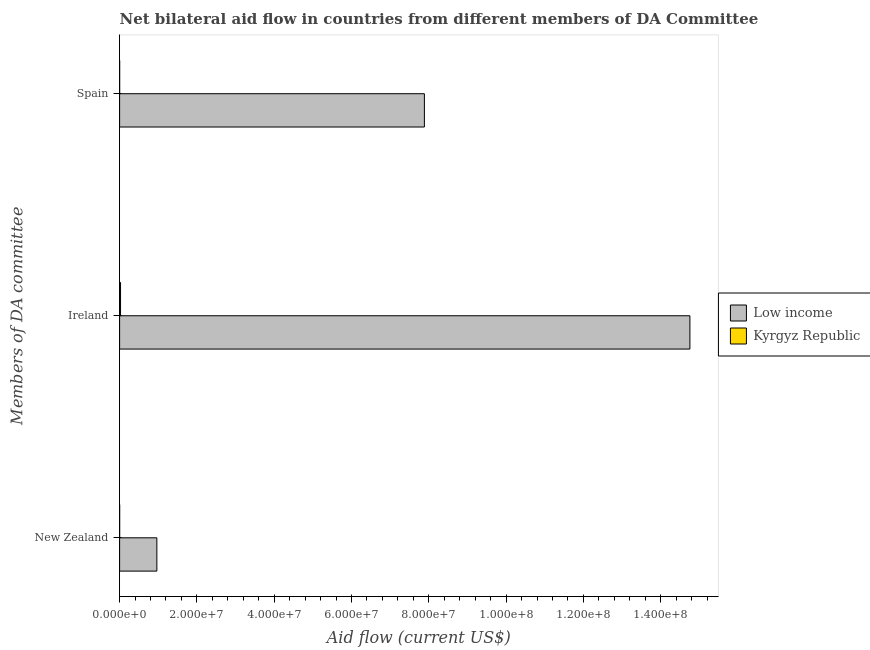How many groups of bars are there?
Ensure brevity in your answer.  3. Are the number of bars per tick equal to the number of legend labels?
Your answer should be compact. Yes. Are the number of bars on each tick of the Y-axis equal?
Keep it short and to the point. Yes. How many bars are there on the 1st tick from the top?
Provide a short and direct response. 2. How many bars are there on the 2nd tick from the bottom?
Ensure brevity in your answer.  2. What is the label of the 3rd group of bars from the top?
Offer a terse response. New Zealand. What is the amount of aid provided by spain in Low income?
Offer a very short reply. 7.89e+07. Across all countries, what is the maximum amount of aid provided by spain?
Make the answer very short. 7.89e+07. Across all countries, what is the minimum amount of aid provided by new zealand?
Ensure brevity in your answer.  10000. In which country was the amount of aid provided by new zealand maximum?
Keep it short and to the point. Low income. In which country was the amount of aid provided by ireland minimum?
Offer a terse response. Kyrgyz Republic. What is the total amount of aid provided by new zealand in the graph?
Keep it short and to the point. 9.65e+06. What is the difference between the amount of aid provided by spain in Low income and that in Kyrgyz Republic?
Make the answer very short. 7.88e+07. What is the difference between the amount of aid provided by ireland in Low income and the amount of aid provided by new zealand in Kyrgyz Republic?
Provide a succinct answer. 1.48e+08. What is the average amount of aid provided by new zealand per country?
Offer a very short reply. 4.82e+06. What is the difference between the amount of aid provided by spain and amount of aid provided by ireland in Kyrgyz Republic?
Offer a very short reply. -2.30e+05. In how many countries, is the amount of aid provided by ireland greater than 80000000 US$?
Offer a terse response. 1. What is the ratio of the amount of aid provided by ireland in Kyrgyz Republic to that in Low income?
Give a very brief answer. 0. Is the difference between the amount of aid provided by new zealand in Kyrgyz Republic and Low income greater than the difference between the amount of aid provided by spain in Kyrgyz Republic and Low income?
Give a very brief answer. Yes. What is the difference between the highest and the second highest amount of aid provided by new zealand?
Make the answer very short. 9.63e+06. What is the difference between the highest and the lowest amount of aid provided by new zealand?
Give a very brief answer. 9.63e+06. Is the sum of the amount of aid provided by spain in Kyrgyz Republic and Low income greater than the maximum amount of aid provided by ireland across all countries?
Your response must be concise. No. What does the 1st bar from the top in Ireland represents?
Your response must be concise. Kyrgyz Republic. What does the 2nd bar from the bottom in New Zealand represents?
Make the answer very short. Kyrgyz Republic. Is it the case that in every country, the sum of the amount of aid provided by new zealand and amount of aid provided by ireland is greater than the amount of aid provided by spain?
Ensure brevity in your answer.  Yes. How many bars are there?
Your response must be concise. 6. What is the difference between two consecutive major ticks on the X-axis?
Give a very brief answer. 2.00e+07. Does the graph contain any zero values?
Keep it short and to the point. No. How many legend labels are there?
Make the answer very short. 2. What is the title of the graph?
Make the answer very short. Net bilateral aid flow in countries from different members of DA Committee. Does "Fragile and conflict affected situations" appear as one of the legend labels in the graph?
Provide a short and direct response. No. What is the label or title of the X-axis?
Your response must be concise. Aid flow (current US$). What is the label or title of the Y-axis?
Give a very brief answer. Members of DA committee. What is the Aid flow (current US$) of Low income in New Zealand?
Offer a terse response. 9.64e+06. What is the Aid flow (current US$) in Kyrgyz Republic in New Zealand?
Offer a terse response. 10000. What is the Aid flow (current US$) in Low income in Ireland?
Give a very brief answer. 1.48e+08. What is the Aid flow (current US$) of Low income in Spain?
Offer a very short reply. 7.89e+07. What is the Aid flow (current US$) in Kyrgyz Republic in Spain?
Offer a very short reply. 10000. Across all Members of DA committee, what is the maximum Aid flow (current US$) of Low income?
Give a very brief answer. 1.48e+08. Across all Members of DA committee, what is the maximum Aid flow (current US$) in Kyrgyz Republic?
Make the answer very short. 2.40e+05. Across all Members of DA committee, what is the minimum Aid flow (current US$) in Low income?
Your answer should be compact. 9.64e+06. Across all Members of DA committee, what is the minimum Aid flow (current US$) of Kyrgyz Republic?
Keep it short and to the point. 10000. What is the total Aid flow (current US$) of Low income in the graph?
Offer a very short reply. 2.36e+08. What is the total Aid flow (current US$) in Kyrgyz Republic in the graph?
Provide a succinct answer. 2.60e+05. What is the difference between the Aid flow (current US$) of Low income in New Zealand and that in Ireland?
Make the answer very short. -1.38e+08. What is the difference between the Aid flow (current US$) in Kyrgyz Republic in New Zealand and that in Ireland?
Ensure brevity in your answer.  -2.30e+05. What is the difference between the Aid flow (current US$) of Low income in New Zealand and that in Spain?
Ensure brevity in your answer.  -6.92e+07. What is the difference between the Aid flow (current US$) in Kyrgyz Republic in New Zealand and that in Spain?
Your answer should be very brief. 0. What is the difference between the Aid flow (current US$) in Low income in Ireland and that in Spain?
Your answer should be compact. 6.87e+07. What is the difference between the Aid flow (current US$) of Kyrgyz Republic in Ireland and that in Spain?
Offer a terse response. 2.30e+05. What is the difference between the Aid flow (current US$) in Low income in New Zealand and the Aid flow (current US$) in Kyrgyz Republic in Ireland?
Offer a terse response. 9.40e+06. What is the difference between the Aid flow (current US$) in Low income in New Zealand and the Aid flow (current US$) in Kyrgyz Republic in Spain?
Your response must be concise. 9.63e+06. What is the difference between the Aid flow (current US$) of Low income in Ireland and the Aid flow (current US$) of Kyrgyz Republic in Spain?
Your answer should be compact. 1.48e+08. What is the average Aid flow (current US$) in Low income per Members of DA committee?
Ensure brevity in your answer.  7.87e+07. What is the average Aid flow (current US$) of Kyrgyz Republic per Members of DA committee?
Your answer should be very brief. 8.67e+04. What is the difference between the Aid flow (current US$) of Low income and Aid flow (current US$) of Kyrgyz Republic in New Zealand?
Give a very brief answer. 9.63e+06. What is the difference between the Aid flow (current US$) in Low income and Aid flow (current US$) in Kyrgyz Republic in Ireland?
Provide a succinct answer. 1.47e+08. What is the difference between the Aid flow (current US$) in Low income and Aid flow (current US$) in Kyrgyz Republic in Spain?
Your response must be concise. 7.88e+07. What is the ratio of the Aid flow (current US$) in Low income in New Zealand to that in Ireland?
Make the answer very short. 0.07. What is the ratio of the Aid flow (current US$) in Kyrgyz Republic in New Zealand to that in Ireland?
Your response must be concise. 0.04. What is the ratio of the Aid flow (current US$) of Low income in New Zealand to that in Spain?
Give a very brief answer. 0.12. What is the ratio of the Aid flow (current US$) of Kyrgyz Republic in New Zealand to that in Spain?
Keep it short and to the point. 1. What is the ratio of the Aid flow (current US$) in Low income in Ireland to that in Spain?
Provide a succinct answer. 1.87. What is the difference between the highest and the second highest Aid flow (current US$) of Low income?
Keep it short and to the point. 6.87e+07. What is the difference between the highest and the second highest Aid flow (current US$) in Kyrgyz Republic?
Your answer should be very brief. 2.30e+05. What is the difference between the highest and the lowest Aid flow (current US$) of Low income?
Ensure brevity in your answer.  1.38e+08. 